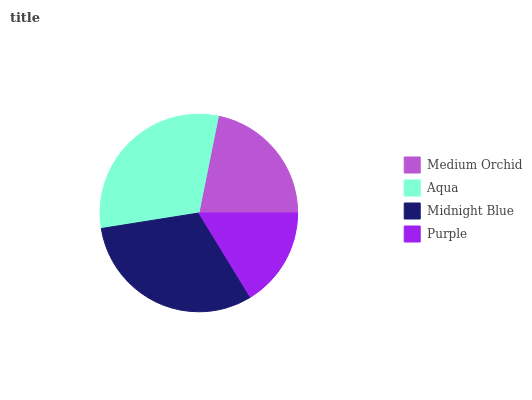Is Purple the minimum?
Answer yes or no. Yes. Is Midnight Blue the maximum?
Answer yes or no. Yes. Is Aqua the minimum?
Answer yes or no. No. Is Aqua the maximum?
Answer yes or no. No. Is Aqua greater than Medium Orchid?
Answer yes or no. Yes. Is Medium Orchid less than Aqua?
Answer yes or no. Yes. Is Medium Orchid greater than Aqua?
Answer yes or no. No. Is Aqua less than Medium Orchid?
Answer yes or no. No. Is Aqua the high median?
Answer yes or no. Yes. Is Medium Orchid the low median?
Answer yes or no. Yes. Is Purple the high median?
Answer yes or no. No. Is Aqua the low median?
Answer yes or no. No. 